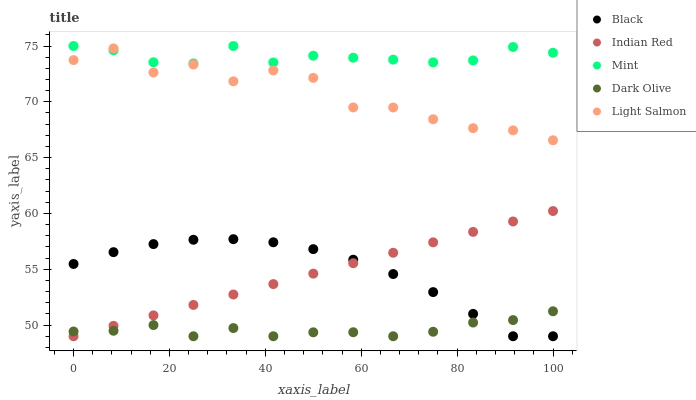Does Dark Olive have the minimum area under the curve?
Answer yes or no. Yes. Does Mint have the maximum area under the curve?
Answer yes or no. Yes. Does Light Salmon have the minimum area under the curve?
Answer yes or no. No. Does Light Salmon have the maximum area under the curve?
Answer yes or no. No. Is Indian Red the smoothest?
Answer yes or no. Yes. Is Light Salmon the roughest?
Answer yes or no. Yes. Is Dark Olive the smoothest?
Answer yes or no. No. Is Dark Olive the roughest?
Answer yes or no. No. Does Dark Olive have the lowest value?
Answer yes or no. Yes. Does Light Salmon have the lowest value?
Answer yes or no. No. Does Mint have the highest value?
Answer yes or no. Yes. Does Light Salmon have the highest value?
Answer yes or no. No. Is Indian Red less than Light Salmon?
Answer yes or no. Yes. Is Mint greater than Dark Olive?
Answer yes or no. Yes. Does Indian Red intersect Dark Olive?
Answer yes or no. Yes. Is Indian Red less than Dark Olive?
Answer yes or no. No. Is Indian Red greater than Dark Olive?
Answer yes or no. No. Does Indian Red intersect Light Salmon?
Answer yes or no. No. 